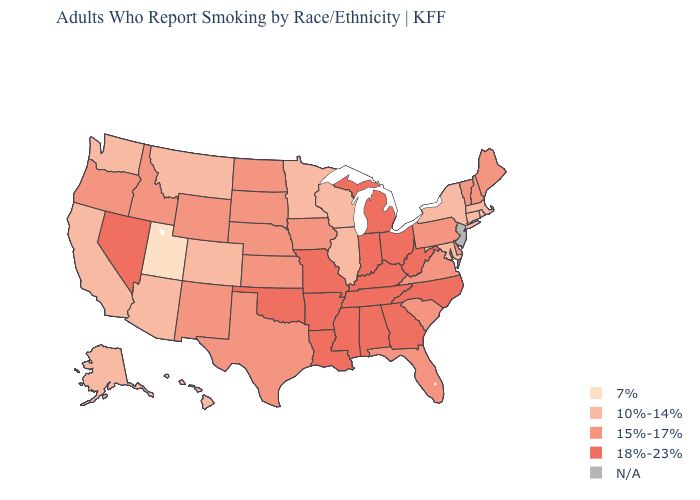What is the value of Wisconsin?
Answer briefly. 10%-14%. What is the value of Utah?
Write a very short answer. 7%. Name the states that have a value in the range 7%?
Write a very short answer. Utah. What is the highest value in the USA?
Write a very short answer. 18%-23%. Among the states that border Pennsylvania , which have the highest value?
Write a very short answer. Ohio, West Virginia. Name the states that have a value in the range 10%-14%?
Give a very brief answer. Alaska, Arizona, California, Colorado, Connecticut, Hawaii, Illinois, Maryland, Massachusetts, Minnesota, Montana, New York, Rhode Island, Washington, Wisconsin. Among the states that border Oregon , does Washington have the lowest value?
Be succinct. Yes. Among the states that border Indiana , which have the highest value?
Short answer required. Kentucky, Michigan, Ohio. Name the states that have a value in the range 15%-17%?
Quick response, please. Delaware, Florida, Idaho, Iowa, Kansas, Maine, Nebraska, New Hampshire, New Mexico, North Dakota, Oregon, Pennsylvania, South Carolina, South Dakota, Texas, Vermont, Virginia, Wyoming. What is the value of Arkansas?
Write a very short answer. 18%-23%. Among the states that border Iowa , does South Dakota have the lowest value?
Concise answer only. No. How many symbols are there in the legend?
Concise answer only. 5. What is the value of Nebraska?
Keep it brief. 15%-17%. What is the value of Oregon?
Short answer required. 15%-17%. 